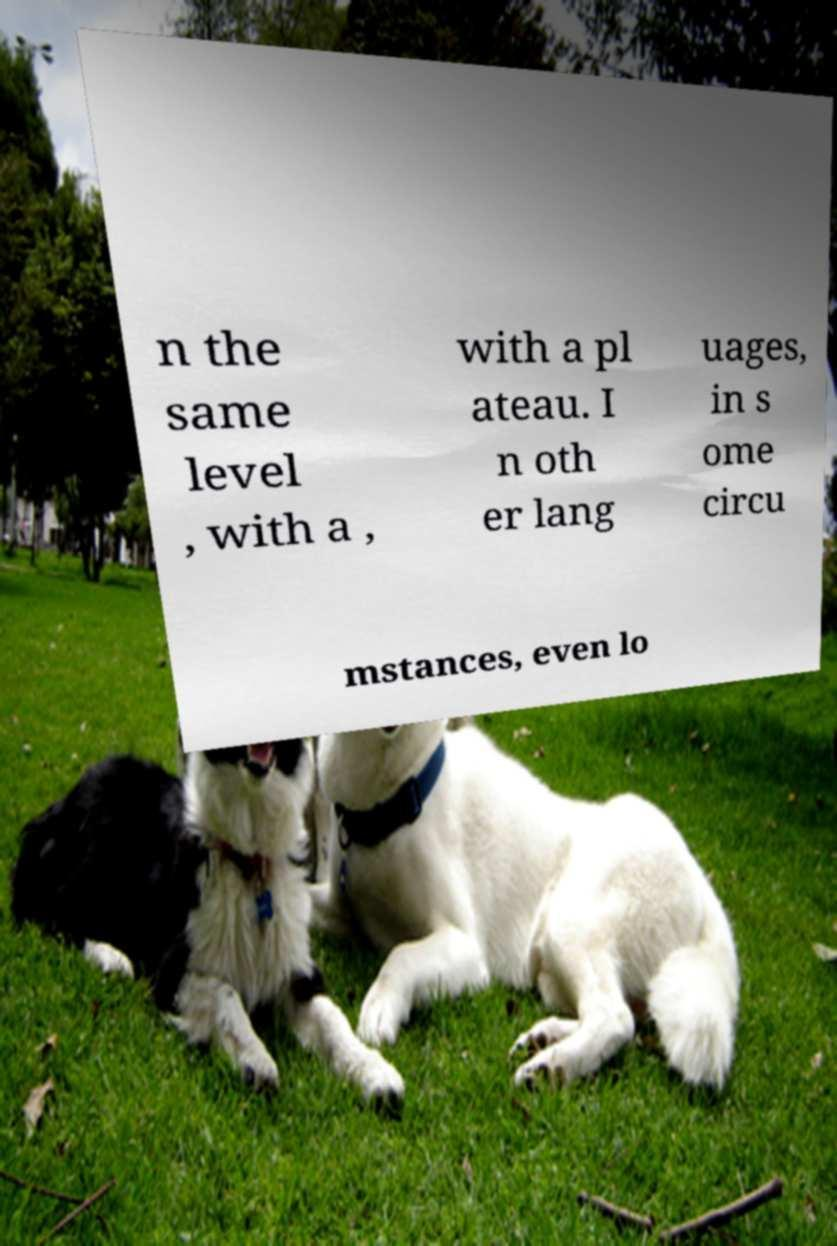I need the written content from this picture converted into text. Can you do that? n the same level , with a , with a pl ateau. I n oth er lang uages, in s ome circu mstances, even lo 